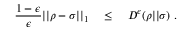Convert formula to latex. <formula><loc_0><loc_0><loc_500><loc_500>{ \frac { 1 - \epsilon } { \epsilon } } | | \rho - \sigma | | _ { 1 } \quad \leq \quad D ^ { \epsilon } ( \rho | | \sigma ) .</formula> 